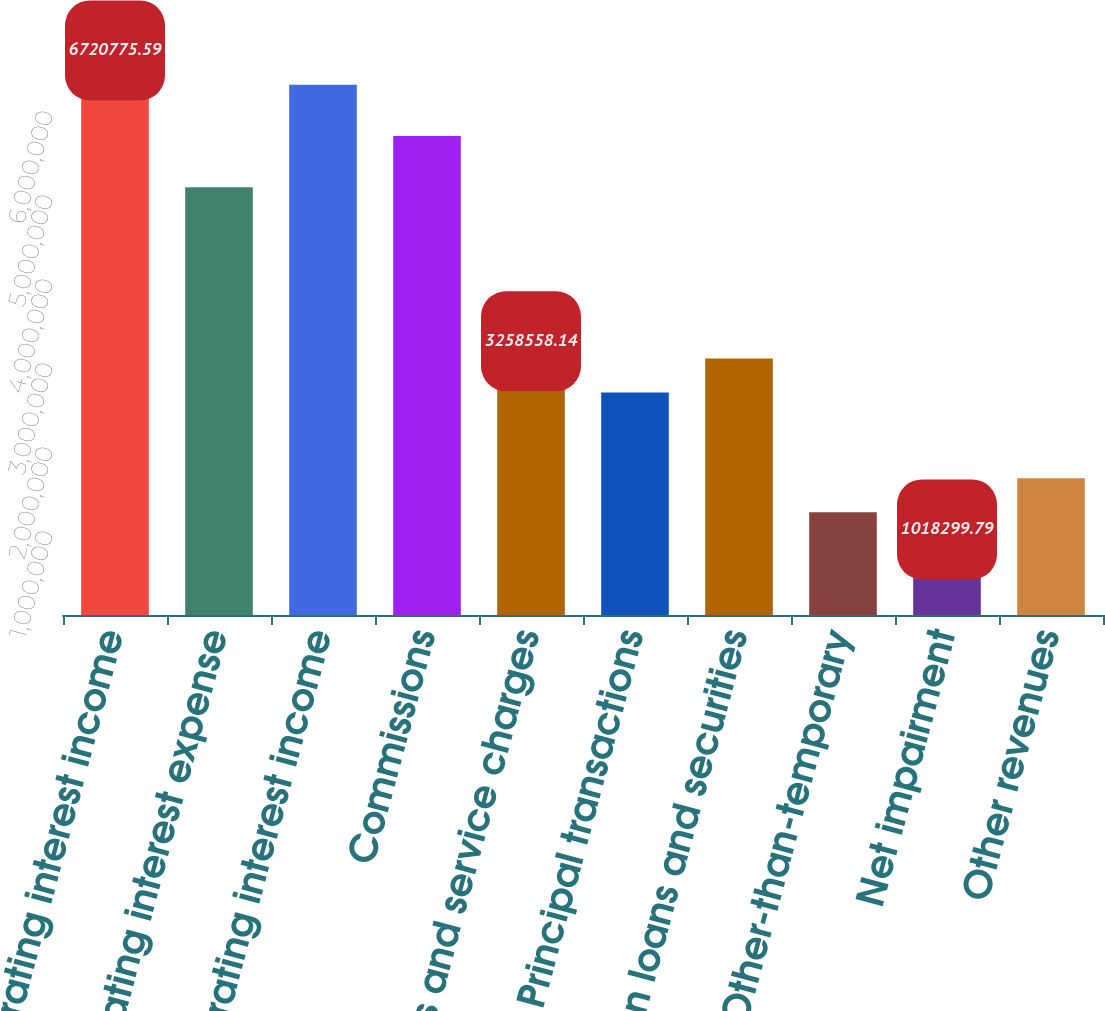<chart> <loc_0><loc_0><loc_500><loc_500><bar_chart><fcel>Operating interest income<fcel>Operating interest expense<fcel>Net operating interest income<fcel>Commissions<fcel>Fees and service charges<fcel>Principal transactions<fcel>Gains on loans and securities<fcel>Other-than-temporary<fcel>Net impairment<fcel>Other revenues<nl><fcel>6.72078e+06<fcel>5.0915e+06<fcel>6.31346e+06<fcel>5.70248e+06<fcel>3.25856e+06<fcel>2.64758e+06<fcel>3.0549e+06<fcel>1.22196e+06<fcel>1.0183e+06<fcel>1.62928e+06<nl></chart> 